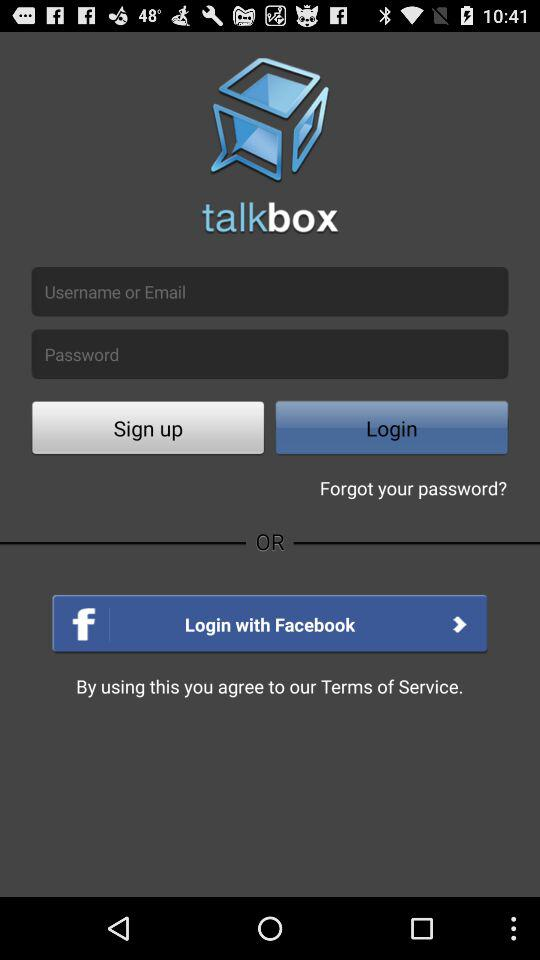What is the entered username?
When the provided information is insufficient, respond with <no answer>. <no answer> 